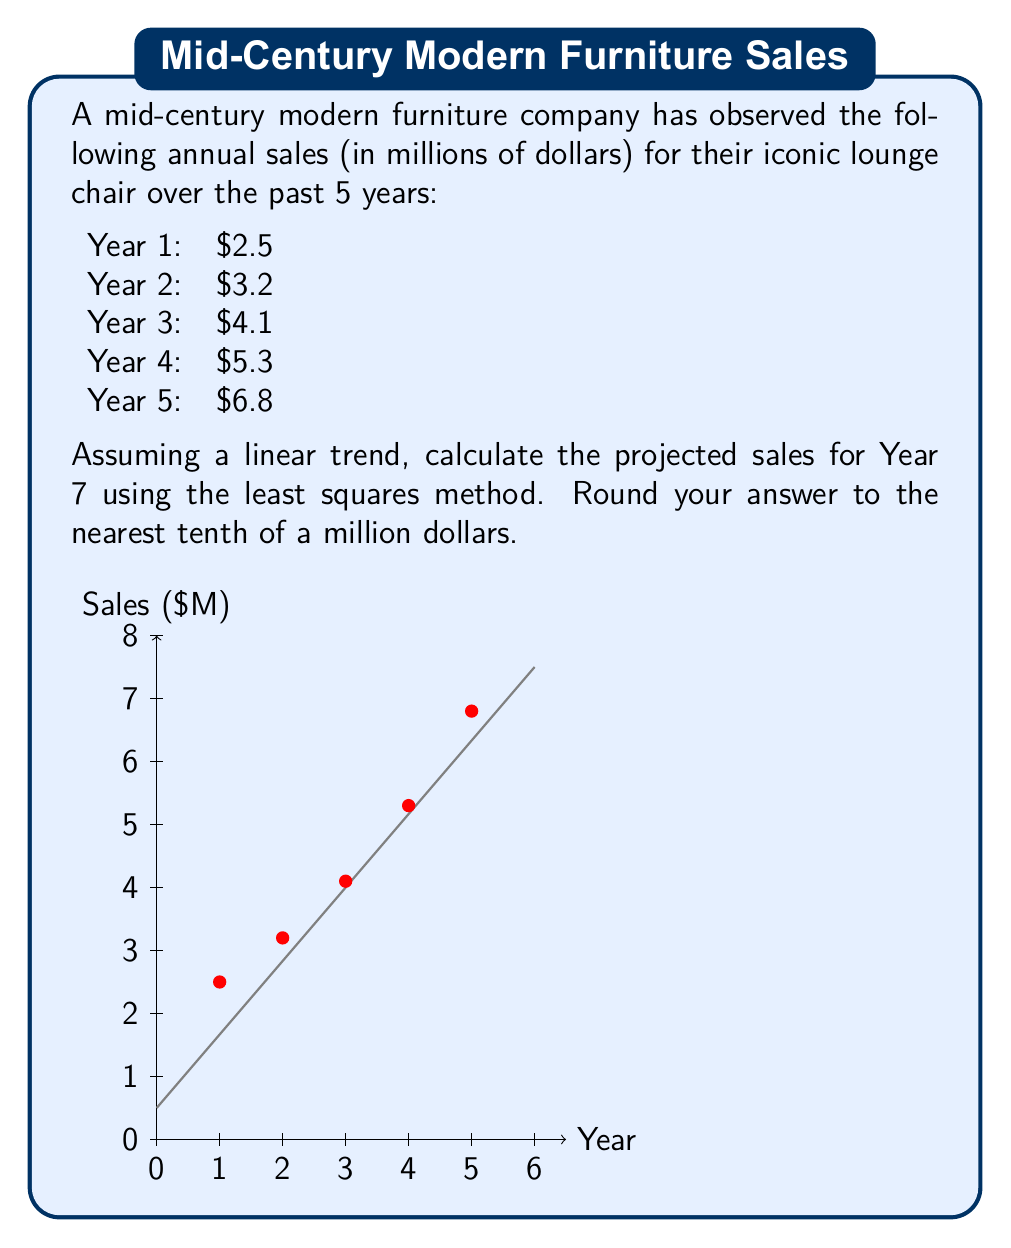Give your solution to this math problem. To solve this problem using the least squares method, we need to follow these steps:

1) First, let's calculate the means of x (years) and y (sales):
   $\bar{x} = \frac{1+2+3+4+5}{5} = 3$
   $\bar{y} = \frac{2.5+3.2+4.1+5.3+6.8}{5} = 4.38$

2) Now, we need to calculate $\sum(x-\bar{x})(y-\bar{y})$ and $\sum(x-\bar{x})^2$:

   $\sum(x-\bar{x})(y-\bar{y}) = (-2)(-1.88) + (-1)(-1.18) + (0)(-0.28) + (1)(0.92) + (2)(2.42) = 10.6$

   $\sum(x-\bar{x})^2 = (-2)^2 + (-1)^2 + 0^2 + 1^2 + 2^2 = 10$

3) The slope (b) of the line is given by:
   $b = \frac{\sum(x-\bar{x})(y-\bar{y})}{\sum(x-\bar{x})^2} = \frac{10.6}{10} = 1.06$

4) We can find the y-intercept (a) using:
   $a = \bar{y} - b\bar{x} = 4.38 - (1.06)(3) = 1.2$

5) Our linear equation is therefore:
   $y = 1.2 + 1.06x$

6) To project sales for Year 7, we substitute x = 7:
   $y = 1.2 + 1.06(7) = 8.62$

7) Rounding to the nearest tenth:
   $8.62 \approx 8.6$
Answer: $8.6 million 